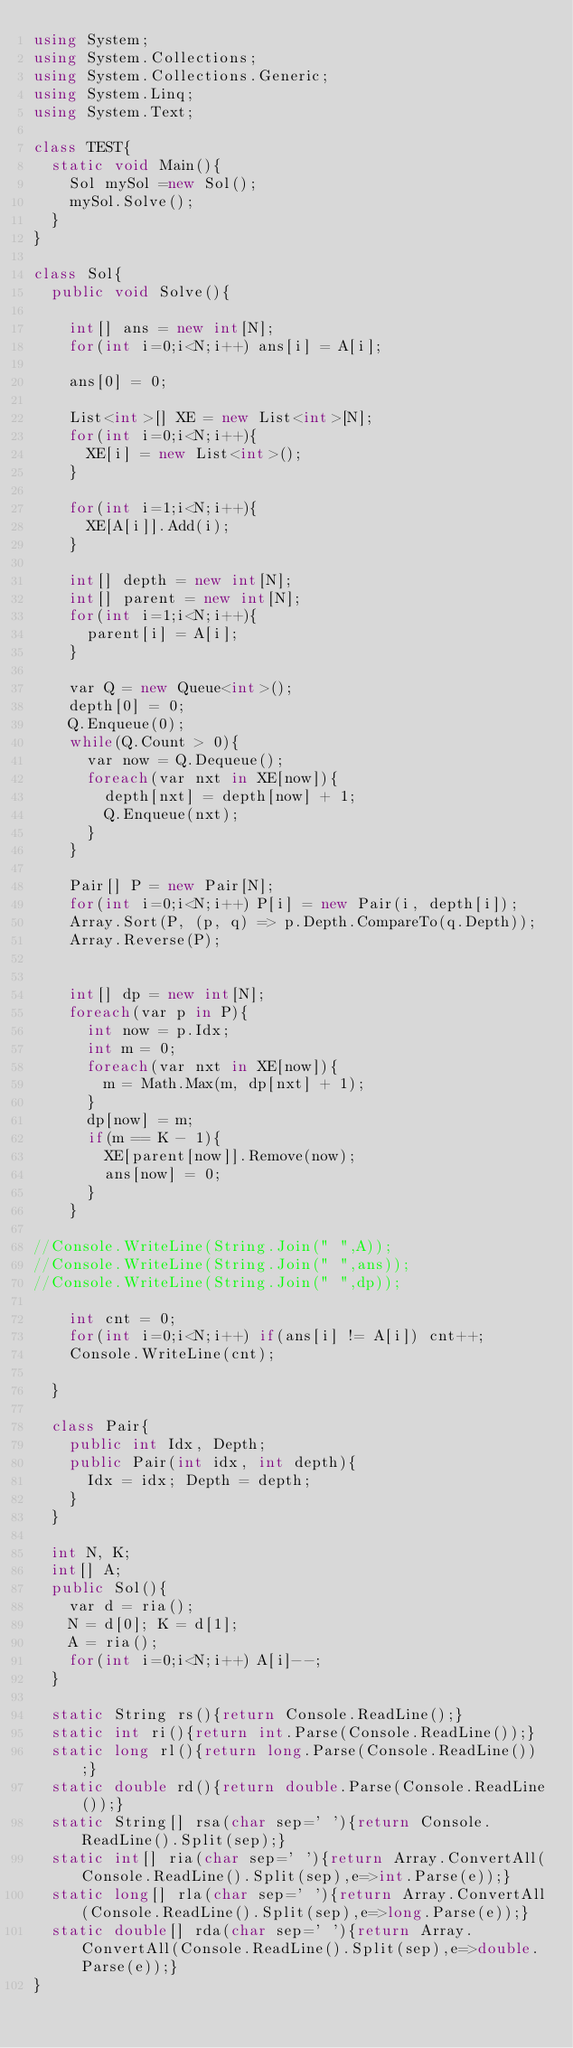Convert code to text. <code><loc_0><loc_0><loc_500><loc_500><_C#_>using System;
using System.Collections;
using System.Collections.Generic;
using System.Linq;
using System.Text;

class TEST{
	static void Main(){
		Sol mySol =new Sol();
		mySol.Solve();
	}
}

class Sol{
	public void Solve(){
		
		int[] ans = new int[N];
		for(int i=0;i<N;i++) ans[i] = A[i];
		
		ans[0] = 0;
		
		List<int>[] XE = new List<int>[N];
		for(int i=0;i<N;i++){
			XE[i] = new List<int>();
		}
		
		for(int i=1;i<N;i++){
			XE[A[i]].Add(i);
		}
		
		int[] depth = new int[N];
		int[] parent = new int[N];
		for(int i=1;i<N;i++){
			parent[i] = A[i];
		}
		
		var Q = new Queue<int>();
		depth[0] = 0;
		Q.Enqueue(0);
		while(Q.Count > 0){
			var now = Q.Dequeue();
			foreach(var nxt in XE[now]){
				depth[nxt] = depth[now] + 1;
				Q.Enqueue(nxt);
			}
		}
		
		Pair[] P = new Pair[N];
		for(int i=0;i<N;i++) P[i] = new Pair(i, depth[i]);
		Array.Sort(P, (p, q) => p.Depth.CompareTo(q.Depth));
		Array.Reverse(P);
		
		
		int[] dp = new int[N];
		foreach(var p in P){
			int now = p.Idx;
			int m = 0;
			foreach(var nxt in XE[now]){
				m = Math.Max(m, dp[nxt] + 1);
			}
			dp[now] = m;
			if(m == K - 1){
				XE[parent[now]].Remove(now);
				ans[now] = 0;
			}
		}
		
//Console.WriteLine(String.Join(" ",A));
//Console.WriteLine(String.Join(" ",ans));
//Console.WriteLine(String.Join(" ",dp));
		
		int cnt = 0;
		for(int i=0;i<N;i++) if(ans[i] != A[i]) cnt++;
		Console.WriteLine(cnt);
		
	}
	
	class Pair{
		public int Idx, Depth;
		public Pair(int idx, int depth){
			Idx = idx; Depth = depth;
		}
	}
	
	int N, K;
	int[] A;
	public Sol(){
		var d = ria();
		N = d[0]; K = d[1];
		A = ria();
		for(int i=0;i<N;i++) A[i]--;
	}

	static String rs(){return Console.ReadLine();}
	static int ri(){return int.Parse(Console.ReadLine());}
	static long rl(){return long.Parse(Console.ReadLine());}
	static double rd(){return double.Parse(Console.ReadLine());}
	static String[] rsa(char sep=' '){return Console.ReadLine().Split(sep);}
	static int[] ria(char sep=' '){return Array.ConvertAll(Console.ReadLine().Split(sep),e=>int.Parse(e));}
	static long[] rla(char sep=' '){return Array.ConvertAll(Console.ReadLine().Split(sep),e=>long.Parse(e));}
	static double[] rda(char sep=' '){return Array.ConvertAll(Console.ReadLine().Split(sep),e=>double.Parse(e));}
}
</code> 